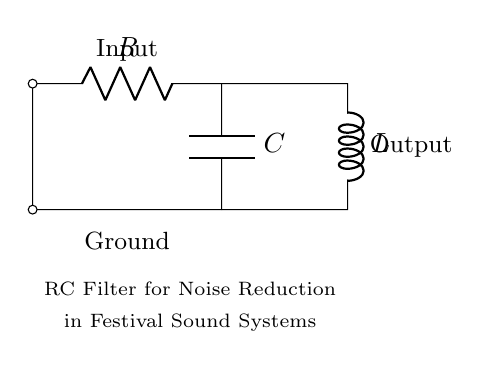What type of filter is represented in this circuit? The circuit diagram indicates an RC filter, as it consists of a resistor (R) and a capacitor (C) arranged in a configuration characteristic of filters.
Answer: RC filter What is the role of the capacitor in this circuit? The capacitor in the RC filter is used to store and release charge, which helps in smoothing out voltage fluctuations and reducing noise in the output signal.
Answer: Noise reduction How many components are there in total in the circuit? There are three main components: one resistor, one capacitor, and one inductor, making a total of three components present.
Answer: Three What is the output connection labelled as? The output connection in the diagram is marked "Output," indicating the point from which the filtered signal is taken.
Answer: Output What does the inductor do in this circuit? The inductor in this circuit contributes to the reactive impedance and can help in further filtering or shaping the frequency response of the circuit alongside the resistor and capacitor.
Answer: Frequency shaping How does increasing the value of the capacitor affect the filter's response? Increasing the value of the capacitor will lower the cutoff frequency of the filter, allowing more low-frequency signals to pass through while blocking higher frequencies, which enhances its noise-reduction capability.
Answer: Lower cutoff frequency Why is this filter design useful in festival sound systems? This filter design is useful in festival sound systems because it helps to minimize unwanted noise, ensuring clearer sound quality for the audience, which is essential for performances and announcements.
Answer: Clearer sound quality 